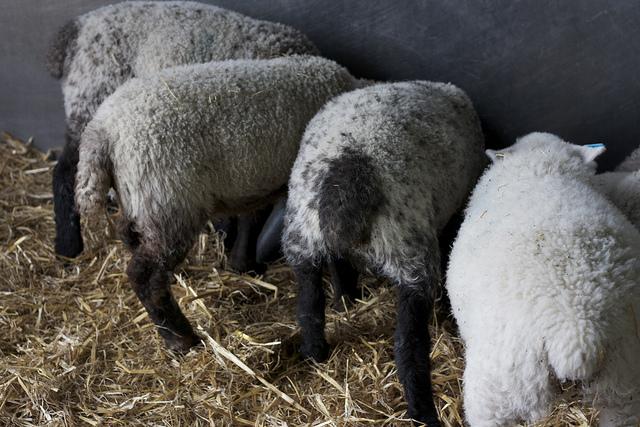Are these animals eating hay?
Quick response, please. Yes. Are the animals fighting?
Concise answer only. No. Are these sheep on the cusp of being too old to nurse?
Short answer required. Yes. 